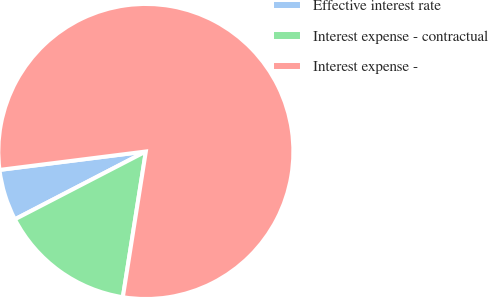<chart> <loc_0><loc_0><loc_500><loc_500><pie_chart><fcel>Effective interest rate<fcel>Interest expense - contractual<fcel>Interest expense -<nl><fcel>5.61%<fcel>14.9%<fcel>79.48%<nl></chart> 